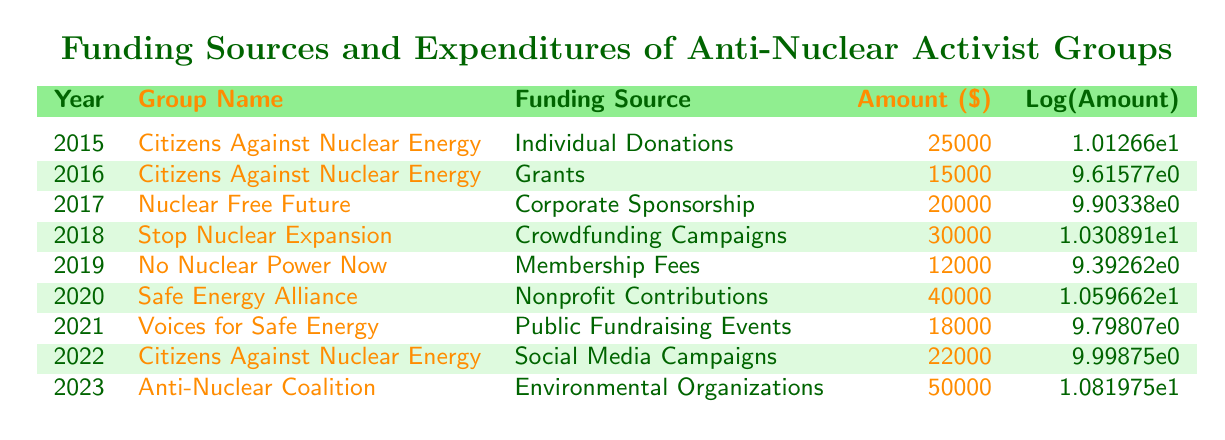What was the amount received from individual donations by Citizens Against Nuclear Energy in 2015? The table shows that in 2015, Citizens Against Nuclear Energy received funding from individual donations, and the amount listed is 25000.
Answer: 25000 What was the total amount of funding received by Safe Energy Alliance over time? The table shows only one entry for Safe Energy Alliance in 2020, where the amount is 40000. Therefore, the total amount of funding received by Safe Energy Alliance is 40000.
Answer: 40000 Did Nuclear Free Future receive funding from grants? Looking at the rows in the table, Nuclear Free Future is listed only once with corporate sponsorship in 2017, indicating that it did not receive funding from grants.
Answer: No What is the funding amount difference between Stop Nuclear Expansion in 2018 and No Nuclear Power Now in 2019? The amount for Stop Nuclear Expansion in 2018 is 30000, and for No Nuclear Power Now in 2019, it is 12000. To find the difference, subtract 12000 from 30000, which equals 18000.
Answer: 18000 Which funding source provided the highest amount in 2023? The table indicates that in 2023, the Anti-Nuclear Coalition received 50000 from environmental organizations, which is the only entry for that year, making it the highest amount.
Answer: 50000 What was the average funding amount over the years 2015 to 2023? The total funding amount from 2015 to 2023 can be calculated by summing the amounts: 25000 + 15000 + 20000 + 30000 + 12000 + 40000 + 18000 + 22000 + 50000 = 187000. Since there are 9 entries, the average is 187000 divided by 9, which is approximately 20777.78.
Answer: 20777.78 Did Citizens Against Nuclear Energy have any crowdfunding campaigns as a funding source? The table shows that Citizens Against Nuclear Energy did not list any crowdfunding campaigns as a funding source; all funding entries for this group were from individual donations, grants, and social media campaigns.
Answer: No Which group received funding from nonprofit contributions, and how much was it? According to the table, Safe Energy Alliance, established in 2020, received funding from nonprofit contributions, totaling 40000.
Answer: 40000 If we look at the amounts for 2021 and 2022, how much funding did Voices for Safe Energy and Citizens Against Nuclear Energy receive combined? The amount for Voices for Safe Energy in 2021 is 18000 and for Citizens Against Nuclear Energy in 2022 is 22000. Adding these together gives 18000 + 22000 = 40000 as the combined funding.
Answer: 40000 